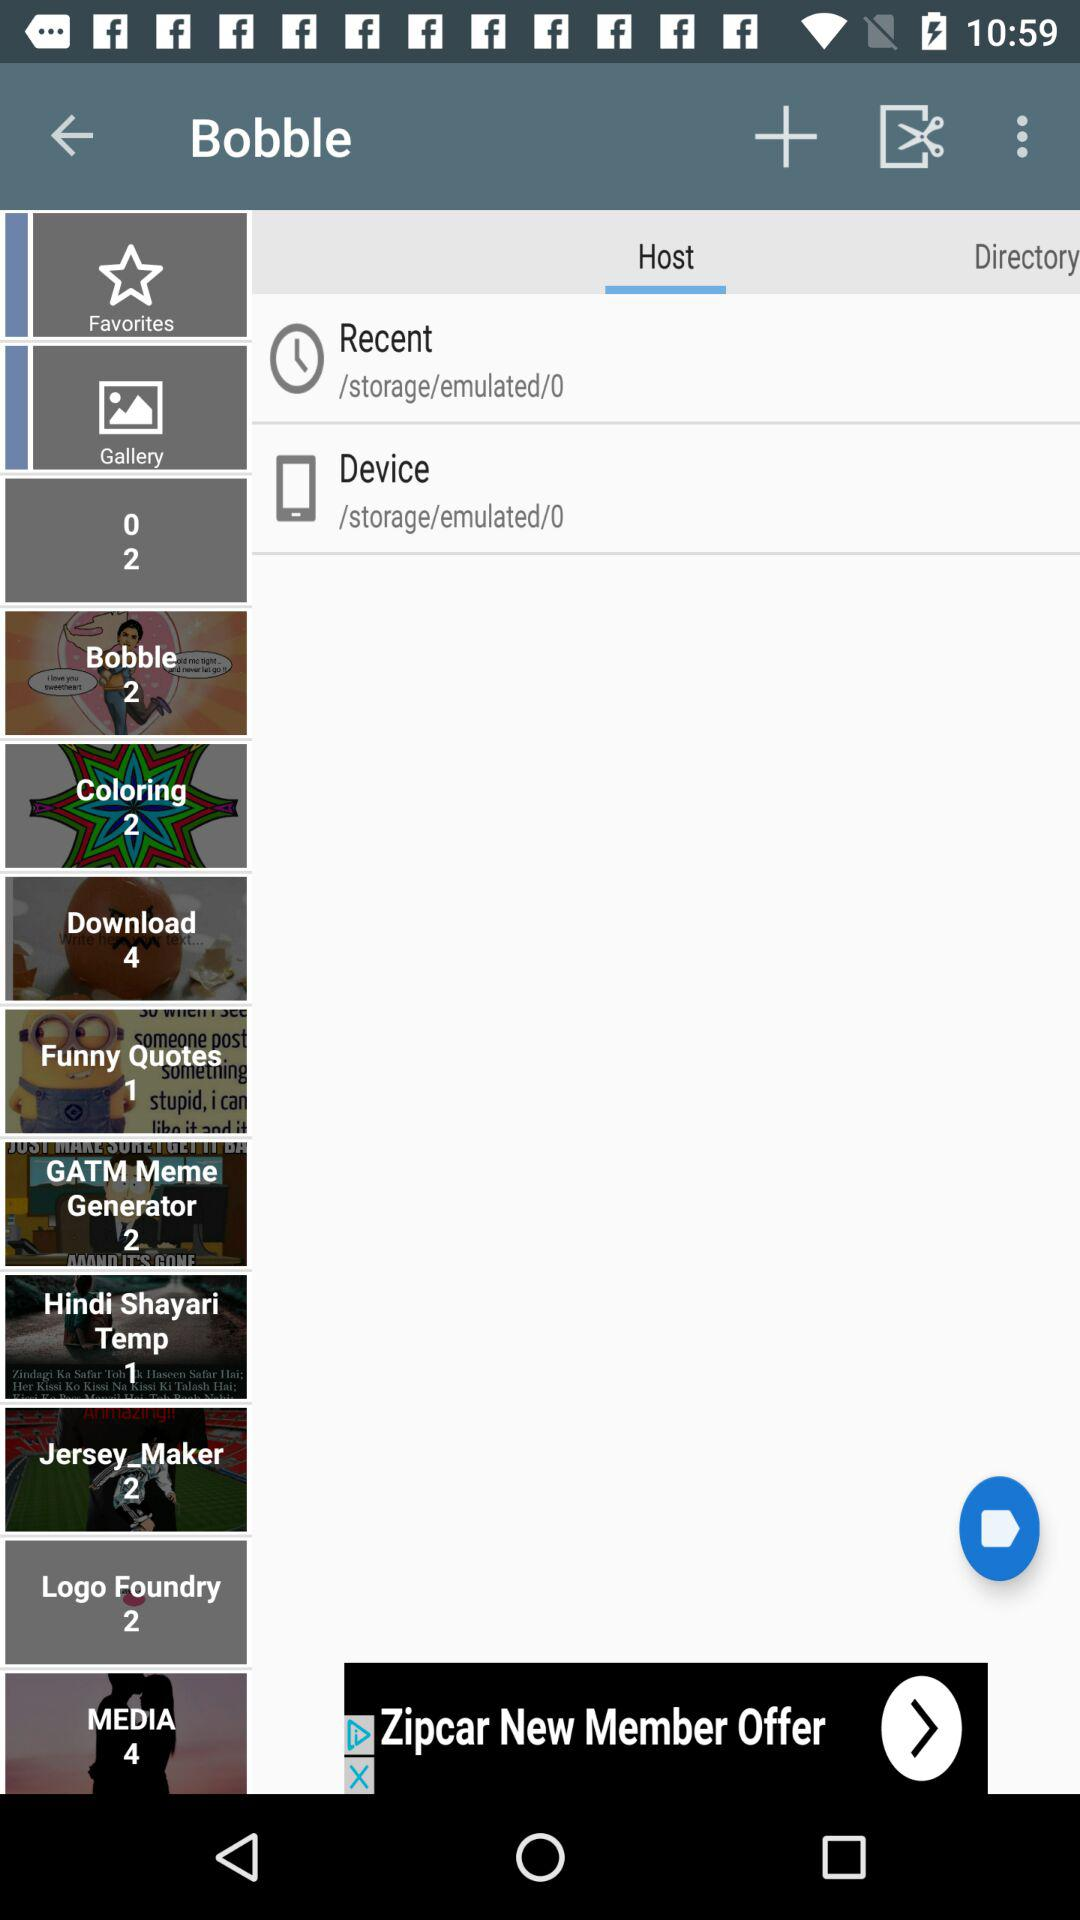What is the number in Coloring?
When the provided information is insufficient, respond with <no answer>. <no answer> 